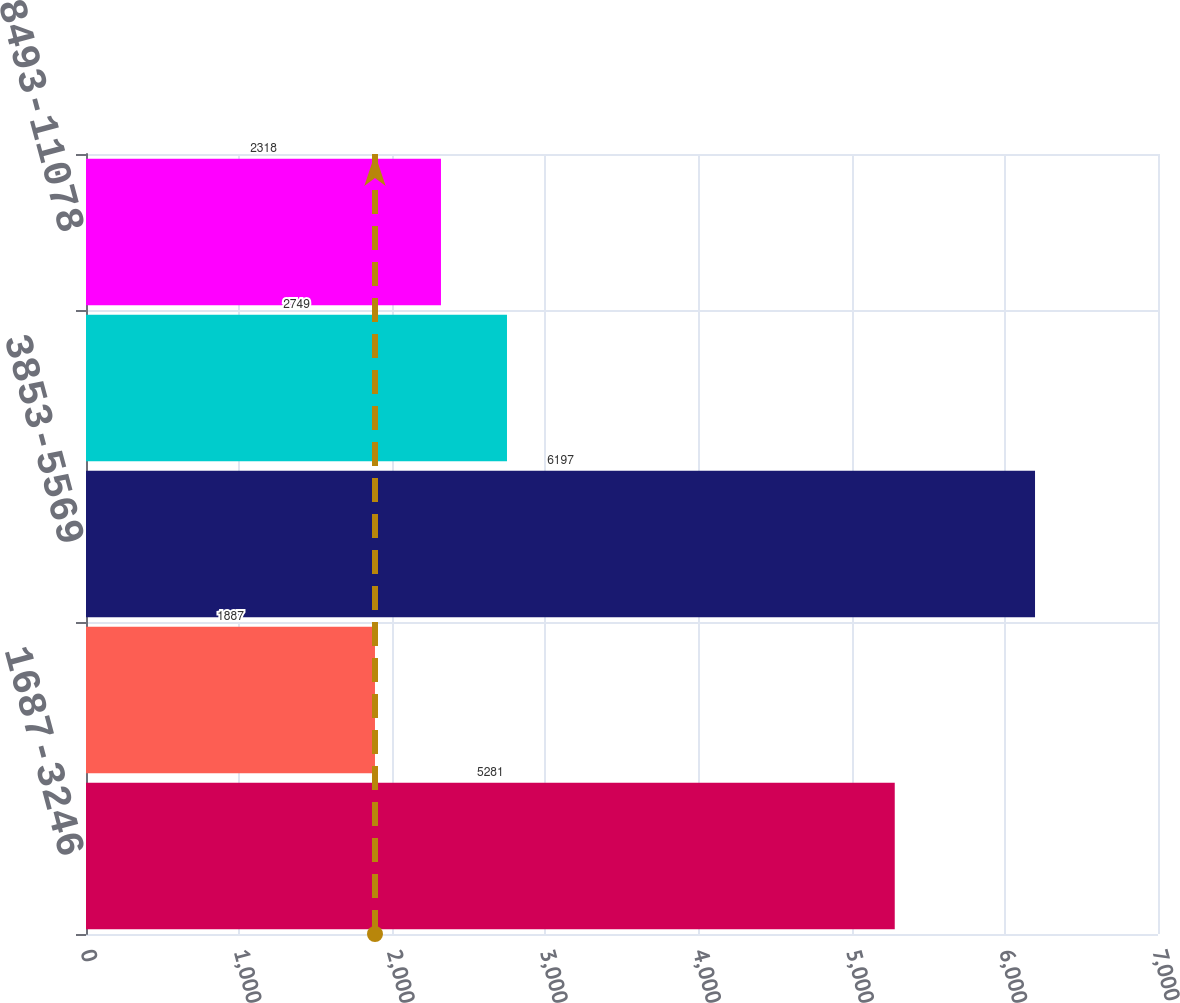Convert chart to OTSL. <chart><loc_0><loc_0><loc_500><loc_500><bar_chart><fcel>1687-3246<fcel>3262-3785<fcel>3853-5569<fcel>5661-7400<fcel>8493-11078<nl><fcel>5281<fcel>1887<fcel>6197<fcel>2749<fcel>2318<nl></chart> 